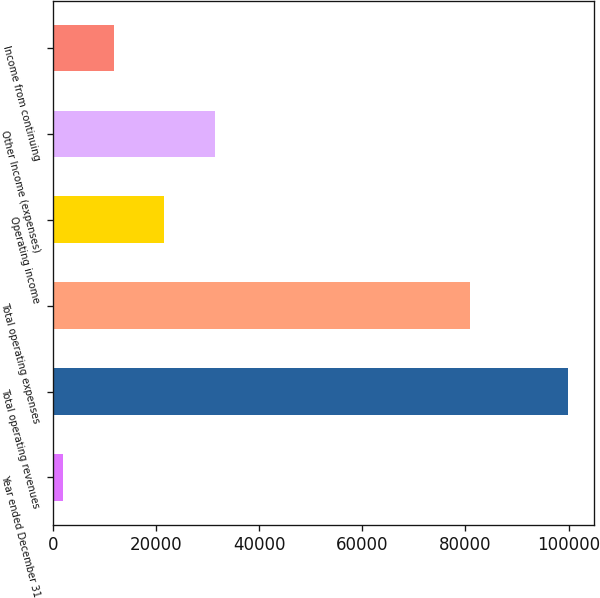Convert chart to OTSL. <chart><loc_0><loc_0><loc_500><loc_500><bar_chart><fcel>Year ended December 31<fcel>Total operating revenues<fcel>Total operating expenses<fcel>Operating income<fcel>Other Income (expenses)<fcel>Income from continuing<nl><fcel>2004<fcel>99873<fcel>80944<fcel>21577.8<fcel>31364.7<fcel>11790.9<nl></chart> 